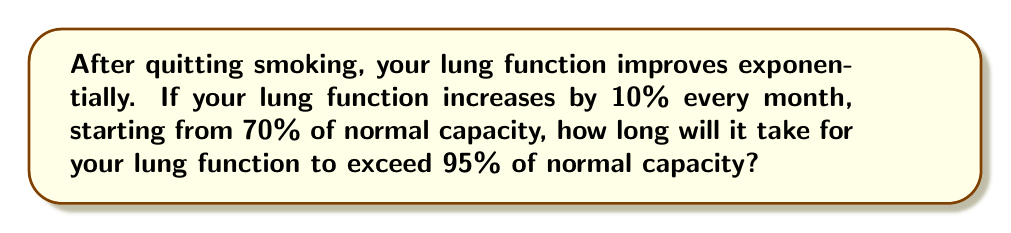Show me your answer to this math problem. Let's approach this step-by-step:

1) Let's define our sequence:
   $a_n = 70 \times (1.1)^n$, where $n$ is the number of months and $a_n$ is the lung function percentage.

2) We want to find $n$ where $a_n > 95$:
   $70 \times (1.1)^n > 95$

3) Dividing both sides by 70:
   $(1.1)^n > \frac{95}{70}$

4) Taking the natural log of both sides:
   $n \times \ln(1.1) > \ln(\frac{95}{70})$

5) Solving for $n$:
   $n > \frac{\ln(\frac{95}{70})}{\ln(1.1)}$

6) Calculating:
   $n > \frac{\ln(1.3571)}{\ln(1.1)} \approx 3.0996$

7) Since $n$ must be a whole number of months, we round up to the next integer.

Therefore, it will take 4 months for lung function to exceed 95% of normal capacity.

To verify:
After 3 months: $70 \times (1.1)^3 \approx 93.17\%$
After 4 months: $70 \times (1.1)^4 \approx 102.49\%$
Answer: 4 months 